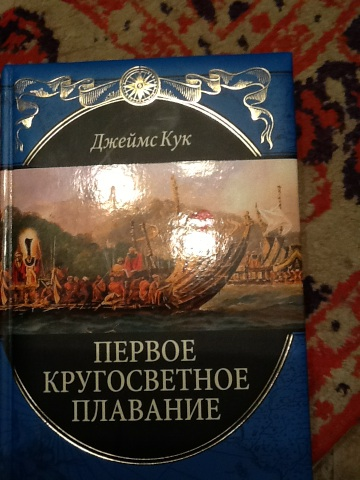Imagine if James Cook found a hidden island with dinosaurs during his voyages. What would his discovery log look like? July 14, 1774: Today, as we ventured further into the uncharted waters of the South Pacific, an astonishing sight met our eyes—an island teeming with creatures none of us had ever seen before. Enormous reptiles, akin to the dragons of ancient lore, roamed the landscape. We beheld creatures with long necks grazing from the treetops, fearsome beasts with teeth as long as a man's forearm, and flying reptiles gliding above. We have named this miraculous land Isla Dinosauria. Our naturalists are fervently documenting the myriad species, and we are taking utmost care to preserve every detail of this when we return to England. This discovery promises to revolutionize our understanding of natural history and the origins of life on Earth. 